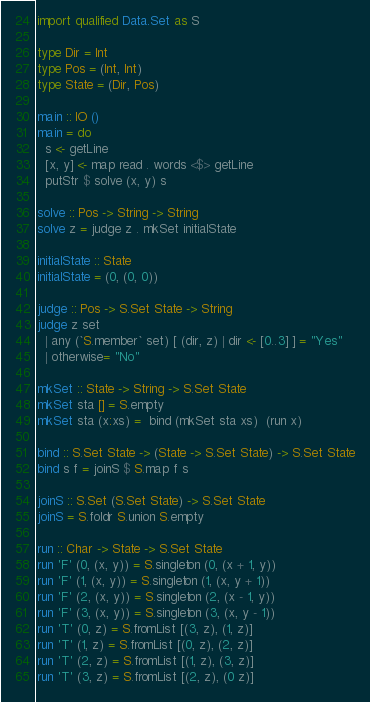<code> <loc_0><loc_0><loc_500><loc_500><_Haskell_>import qualified Data.Set as S
 
type Dir = Int
type Pos = (Int, Int)
type State = (Dir, Pos)
 
main :: IO ()
main = do
  s <- getLine
  [x, y] <- map read . words <$> getLine
  putStr $ solve (x, y) s
 
solve :: Pos -> String -> String
solve z = judge z . mkSet initialState
 
initialState :: State
initialState = (0, (0, 0))
 
judge :: Pos -> S.Set State -> String
judge z set
  | any (`S.member` set) [ (dir, z) | dir <- [0..3] ] = "Yes"
  | otherwise= "No"
 
mkSet :: State -> String -> S.Set State
mkSet sta [] = S.empty
mkSet sta (x:xs) =  bind (mkSet sta xs)  (run x)
 
bind :: S.Set State -> (State -> S.Set State) -> S.Set State
bind s f = joinS $ S.map f s
 
joinS :: S.Set (S.Set State) -> S.Set State
joinS = S.foldr S.union S.empty
 
run :: Char -> State -> S.Set State
run 'F' (0, (x, y)) = S.singleton (0, (x + 1, y))
run 'F' (1, (x, y)) = S.singleton (1, (x, y + 1))
run 'F' (2, (x, y)) = S.singleton (2, (x - 1, y))
run 'F' (3, (x, y)) = S.singleton (3, (x, y - 1))
run 'T' (0, z) = S.fromList [(3, z), (1, z)]
run 'T' (1, z) = S.fromList [(0, z), (2, z)]
run 'T' (2, z) = S.fromList [(1, z), (3, z)]
run 'T' (3, z) = S.fromList [(2, z), (0 z)]</code> 